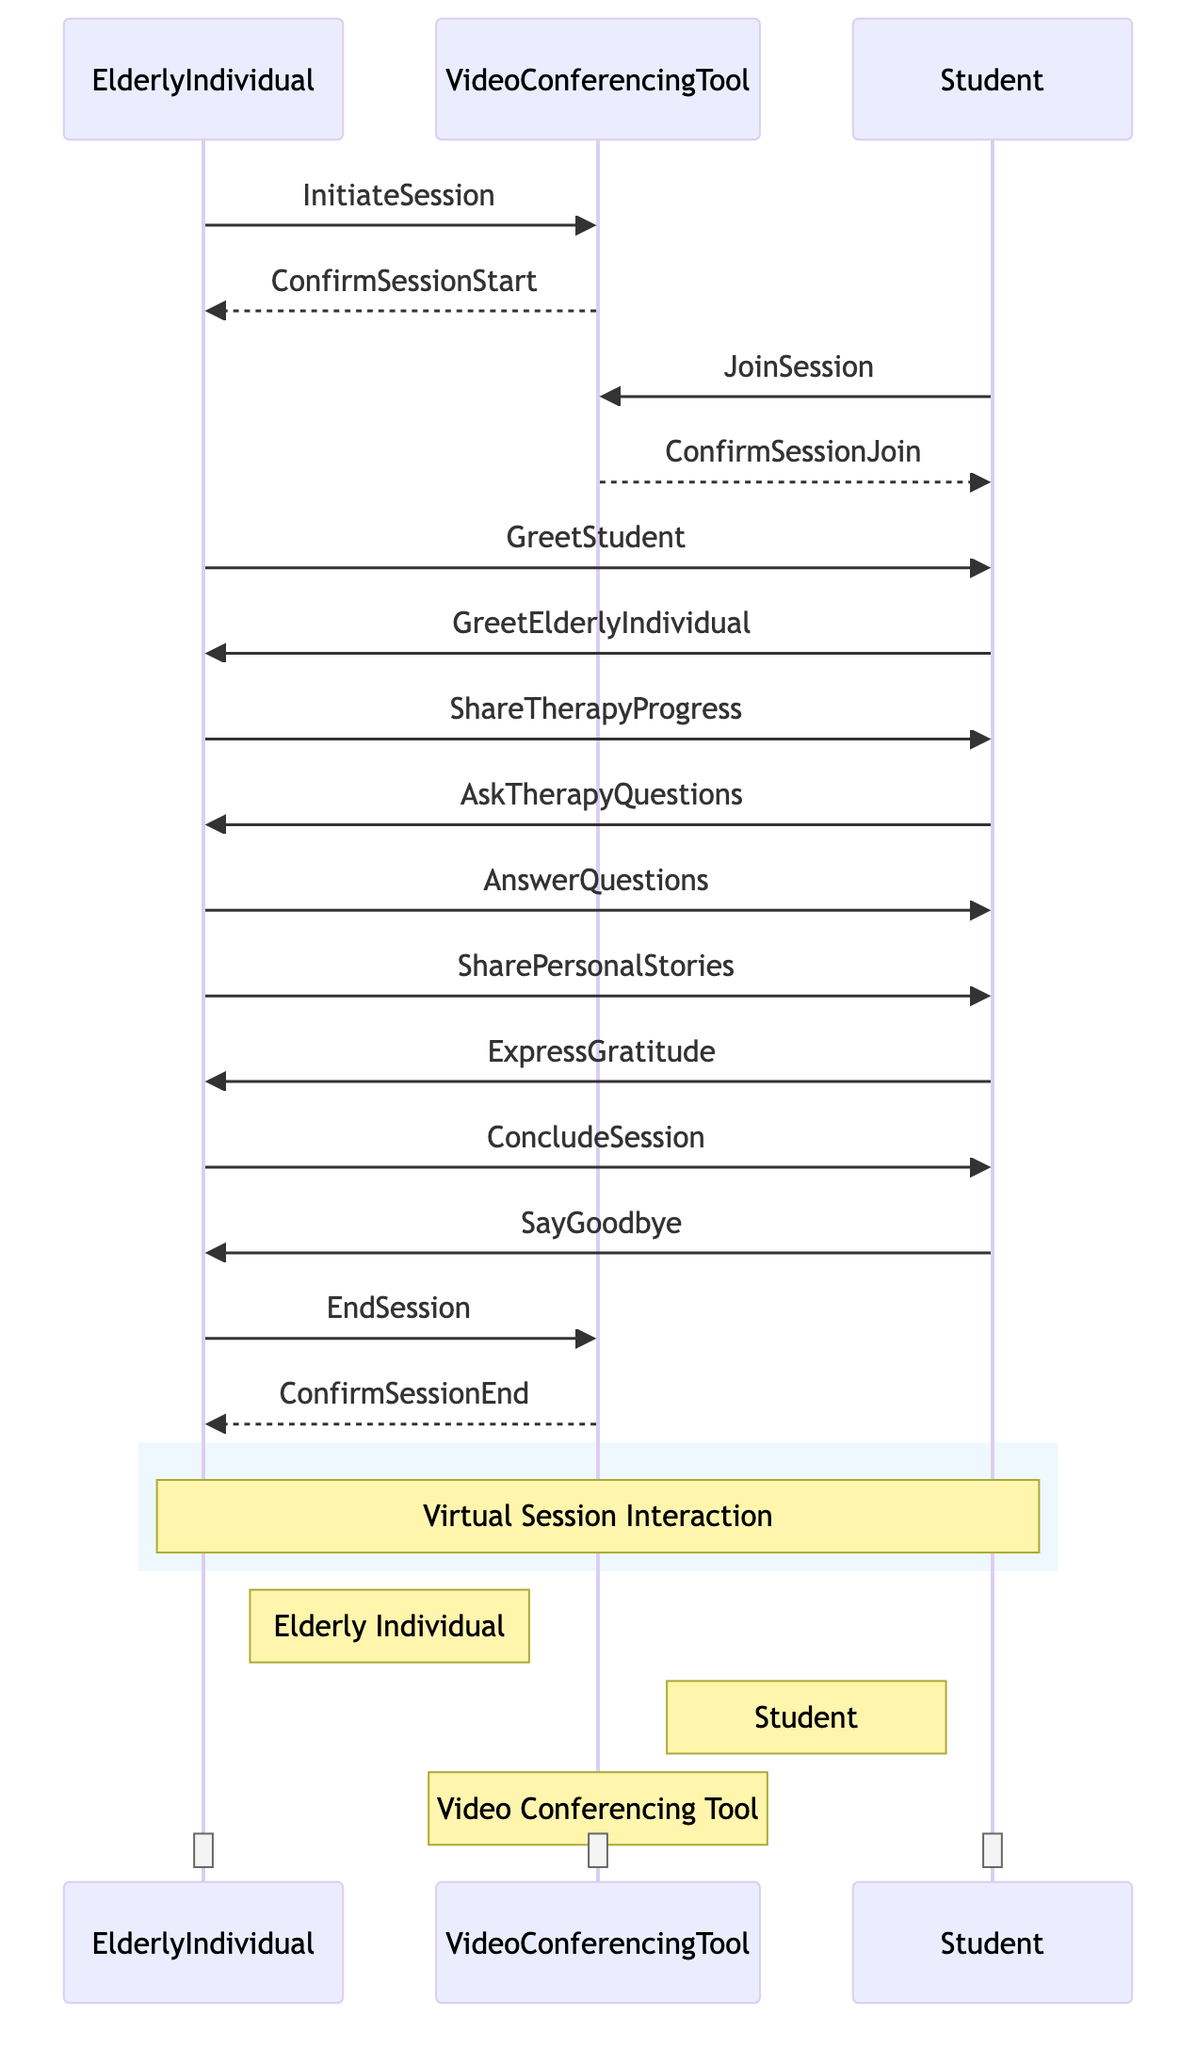What is the first action taken by the Elderly Individual? The first action taken by the Elderly Individual is to initiate the session using the Video Conferencing Tool. This is indicated by the message "InitiateSession" flowing from the Elderly Individual to the Video Conferencing Tool.
Answer: InitiateSession How many total participants are there in the diagram? The diagram contains three participants: Elderly Individual, Student, and Video Conferencing Tool. Therefore, by counting the unique names listed under participants, we find a total of three.
Answer: 3 What is the last communication from the Elderly Individual? The last communication from the Elderly Individual is to end the session with the Video Conferencing Tool. This is seen as the message "EndSession" being sent from Elderly Individual to Video Conferencing Tool, indicating the conclusion of their interaction.
Answer: EndSession Which participant expresses gratitude? The Student expresses gratitude as indicated by the message "ExpressGratitude" which flows from the Student to the Elderly Individual. This shows a direct acknowledgment of the Elderly Individual’s contributions during the session.
Answer: Student What happens after the Elderly Individual shares their therapy progress? After sharing therapy progress, the Student asks therapy questions. This is shown in the sequence, where immediately following the "ShareTherapyProgress" message, the next message is "AskTherapyQuestions" from the Student.
Answer: AskTherapyQuestions How many messages are exchanged between the Student and Elderly Individual? There are six messages exchanged between the Student and the Elderly Individual. These include greetings, questions, answers, sharing personal stories, expressions of gratitude, and the conclusion of the session. By counting every single interaction involving these two participants, we arrive at six.
Answer: 6 Which system facilitates the virtual session? The system that facilitates the virtual session is the Video Conferencing Tool. This is evident as it appears in all communication flows starting from the initiation of the session to its conclusion.
Answer: Video Conferencing Tool What is the response of the Elderly Individual after the Student asks questions? The Elderly Individual answers the questions following the Student's inquiry. This is articulated through the message "AnswerQuestions" that flows from the Elderly Individual to the Student, directly addressing their inquiries.
Answer: AnswerQuestions 